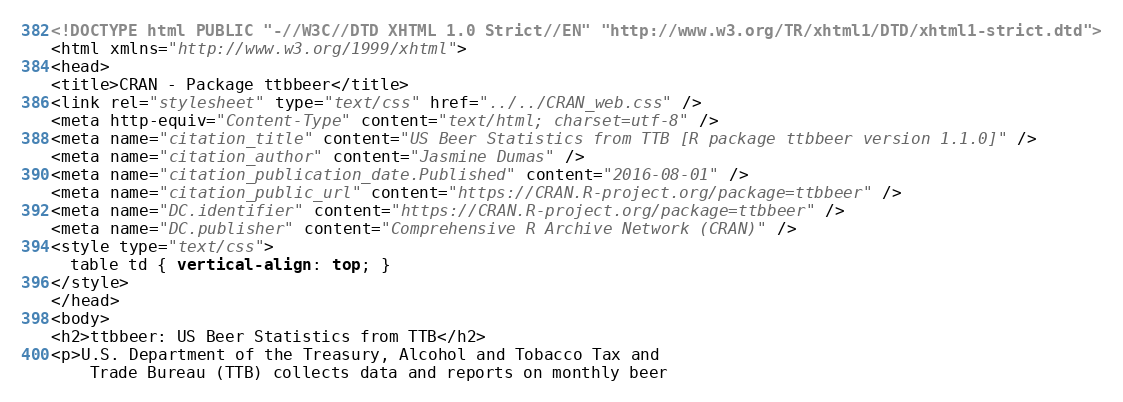Convert code to text. <code><loc_0><loc_0><loc_500><loc_500><_HTML_><!DOCTYPE html PUBLIC "-//W3C//DTD XHTML 1.0 Strict//EN" "http://www.w3.org/TR/xhtml1/DTD/xhtml1-strict.dtd">
<html xmlns="http://www.w3.org/1999/xhtml">
<head>
<title>CRAN - Package ttbbeer</title>
<link rel="stylesheet" type="text/css" href="../../CRAN_web.css" />
<meta http-equiv="Content-Type" content="text/html; charset=utf-8" />
<meta name="citation_title" content="US Beer Statistics from TTB [R package ttbbeer version 1.1.0]" />
<meta name="citation_author" content="Jasmine Dumas" />
<meta name="citation_publication_date.Published" content="2016-08-01" />
<meta name="citation_public_url" content="https://CRAN.R-project.org/package=ttbbeer" />
<meta name="DC.identifier" content="https://CRAN.R-project.org/package=ttbbeer" />
<meta name="DC.publisher" content="Comprehensive R Archive Network (CRAN)" />
<style type="text/css">
  table td { vertical-align: top; }
</style>
</head>
<body>
<h2>ttbbeer: US Beer Statistics from TTB</h2>
<p>U.S. Department of the Treasury, Alcohol and Tobacco Tax and
    Trade Bureau (TTB) collects data and reports on monthly beer</code> 